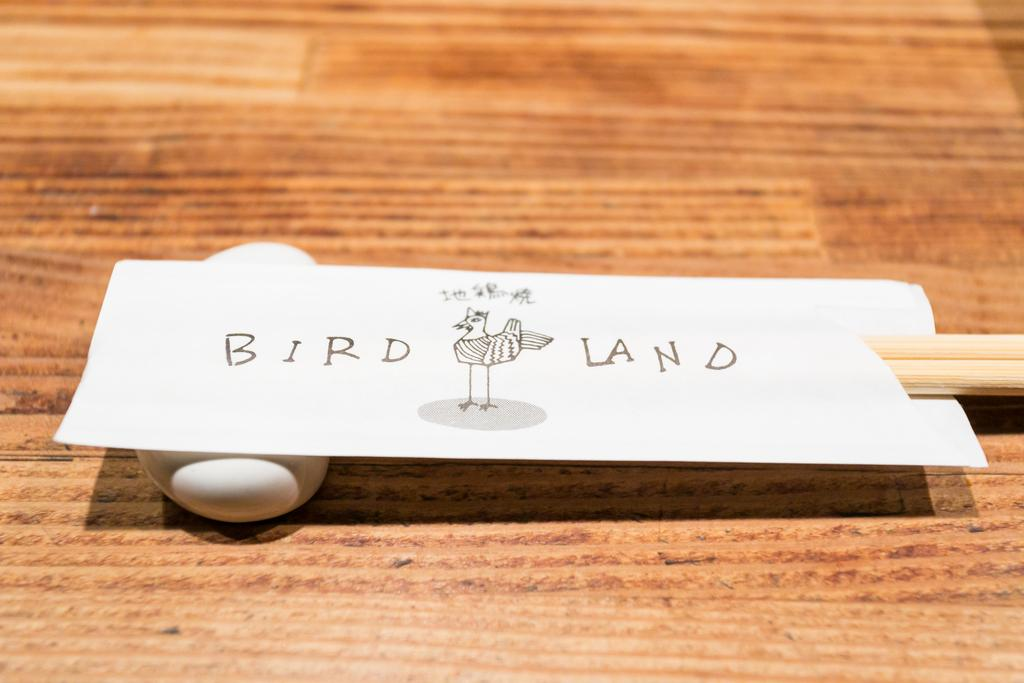What is on the table in the image? There is a white stone on the table. What is on top of the white stone? There is a board on the white stone. What is on the board? There is a wooden stick on the board. What type of orange is visible on the wooden stick in the image? There is no orange present in the image; it features a white stone, a board, and a wooden stick. What is the size of the vegetable on the board in the image? There is no vegetable present on the board in the image; it only has a wooden stick. 